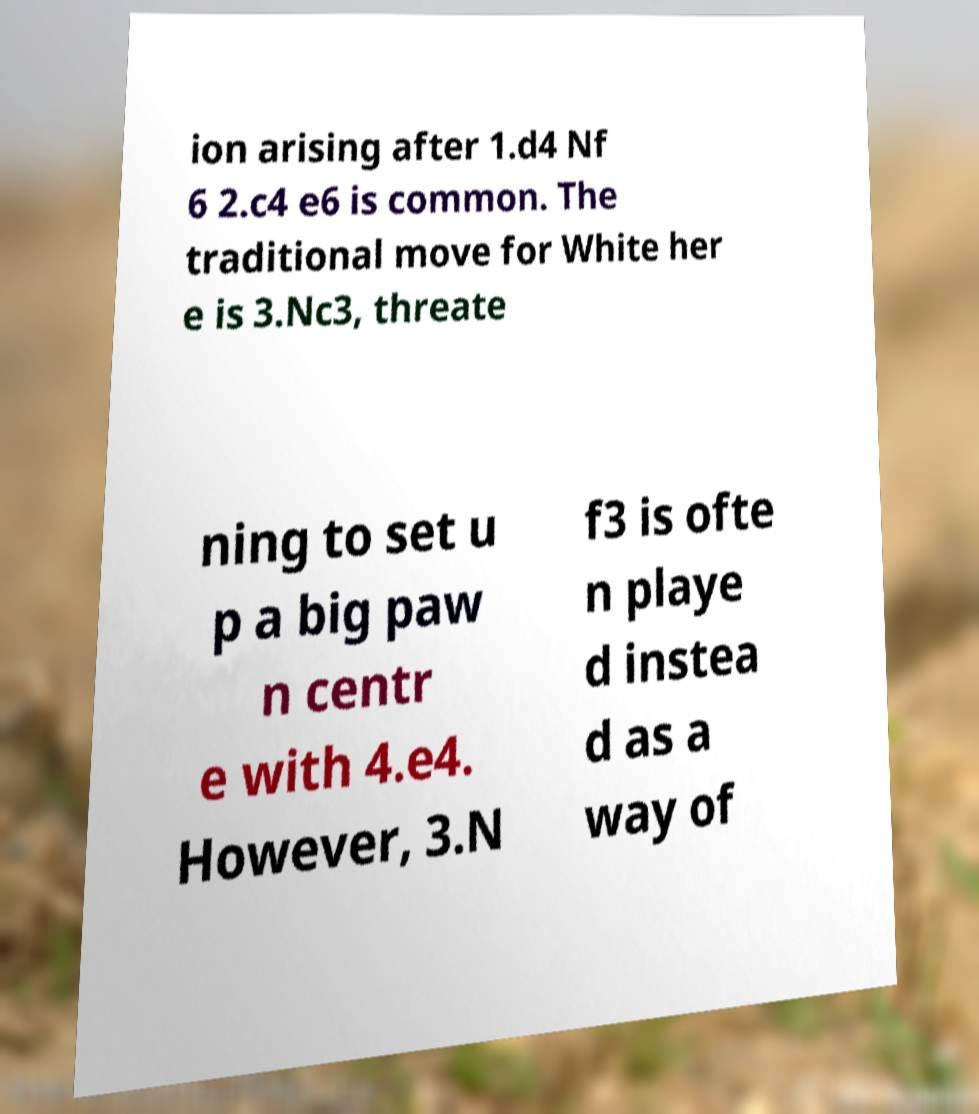Can you read and provide the text displayed in the image?This photo seems to have some interesting text. Can you extract and type it out for me? ion arising after 1.d4 Nf 6 2.c4 e6 is common. The traditional move for White her e is 3.Nc3, threate ning to set u p a big paw n centr e with 4.e4. However, 3.N f3 is ofte n playe d instea d as a way of 